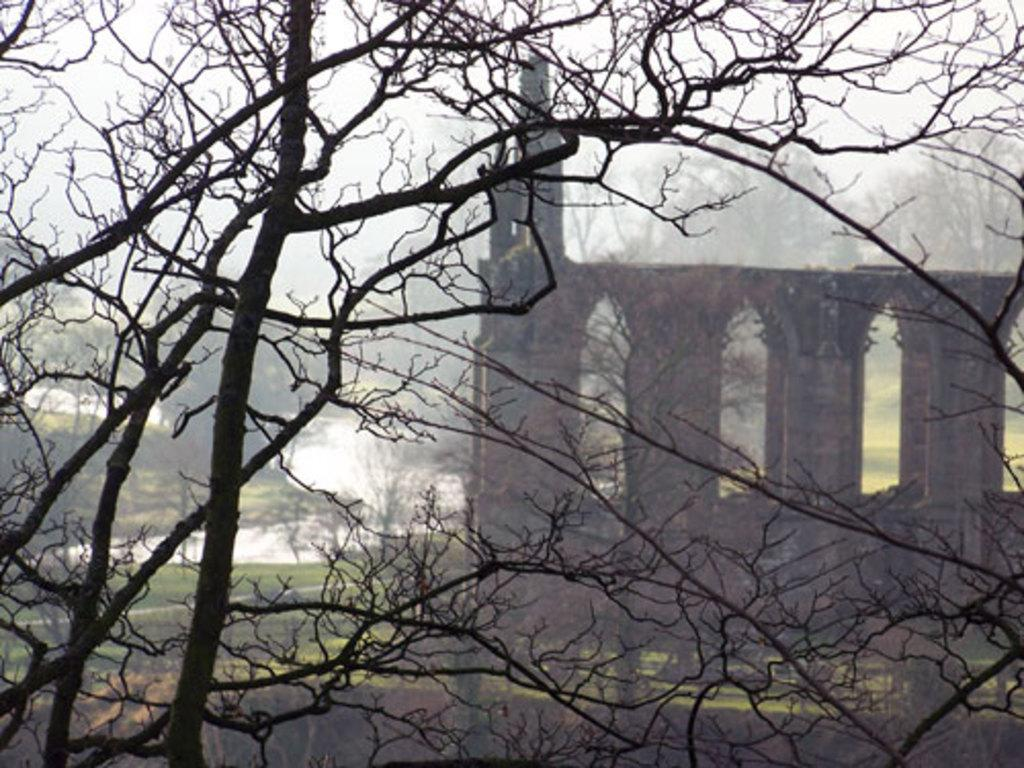What type of natural element can be seen in the image? There is a tree in the image. What type of man-made structure is present in the image? There is a building in the image. What can be seen flowing or covering the ground in the image? There is water visible in the image. What is visible above the tree and building in the image? The sky is visible in the image. Can you tell me how many swings are hanging from the tree in the image? There are no swings present in the image; it features a tree, a building, water, and the sky. What type of story is being told by the building in the image? The building in the image is not telling a story; it is a man-made structure. 